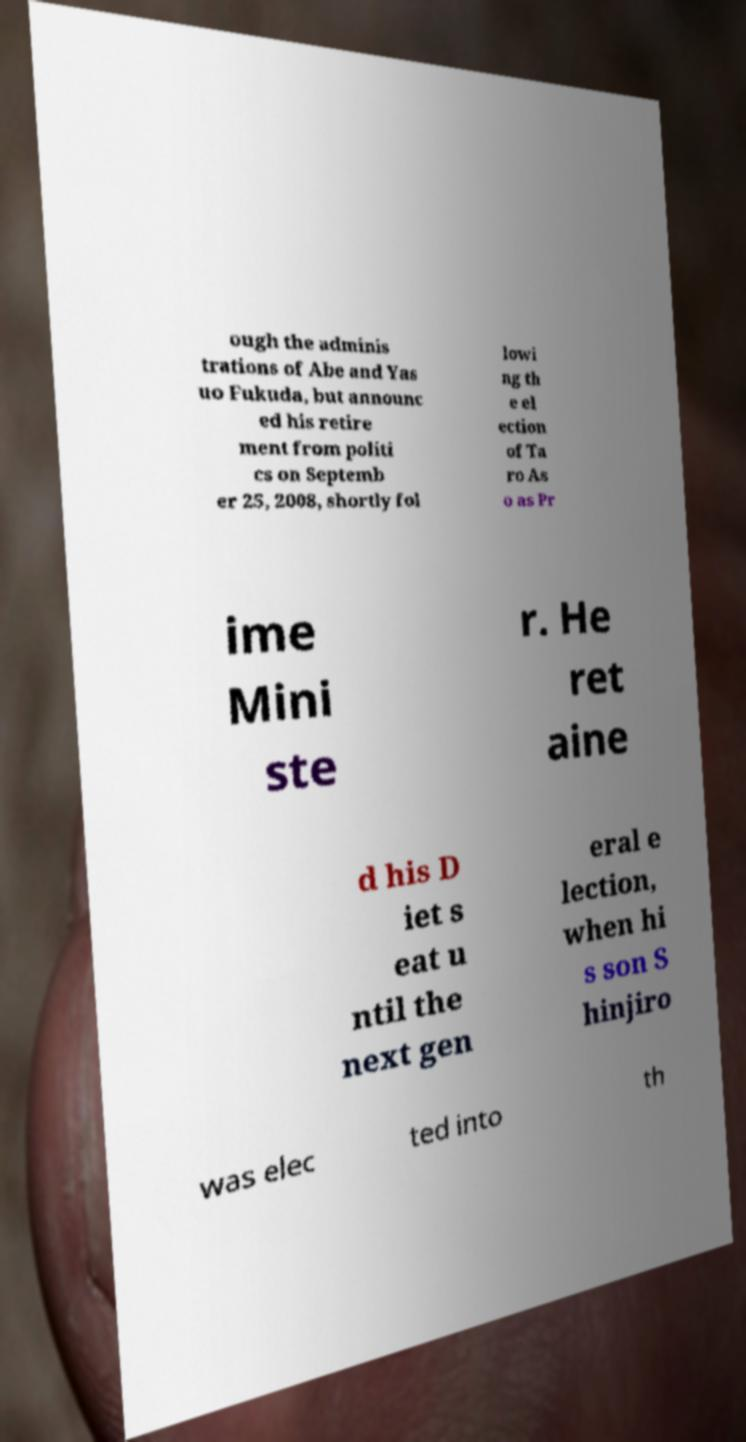Can you read and provide the text displayed in the image?This photo seems to have some interesting text. Can you extract and type it out for me? ough the adminis trations of Abe and Yas uo Fukuda, but announc ed his retire ment from politi cs on Septemb er 25, 2008, shortly fol lowi ng th e el ection of Ta ro As o as Pr ime Mini ste r. He ret aine d his D iet s eat u ntil the next gen eral e lection, when hi s son S hinjiro was elec ted into th 